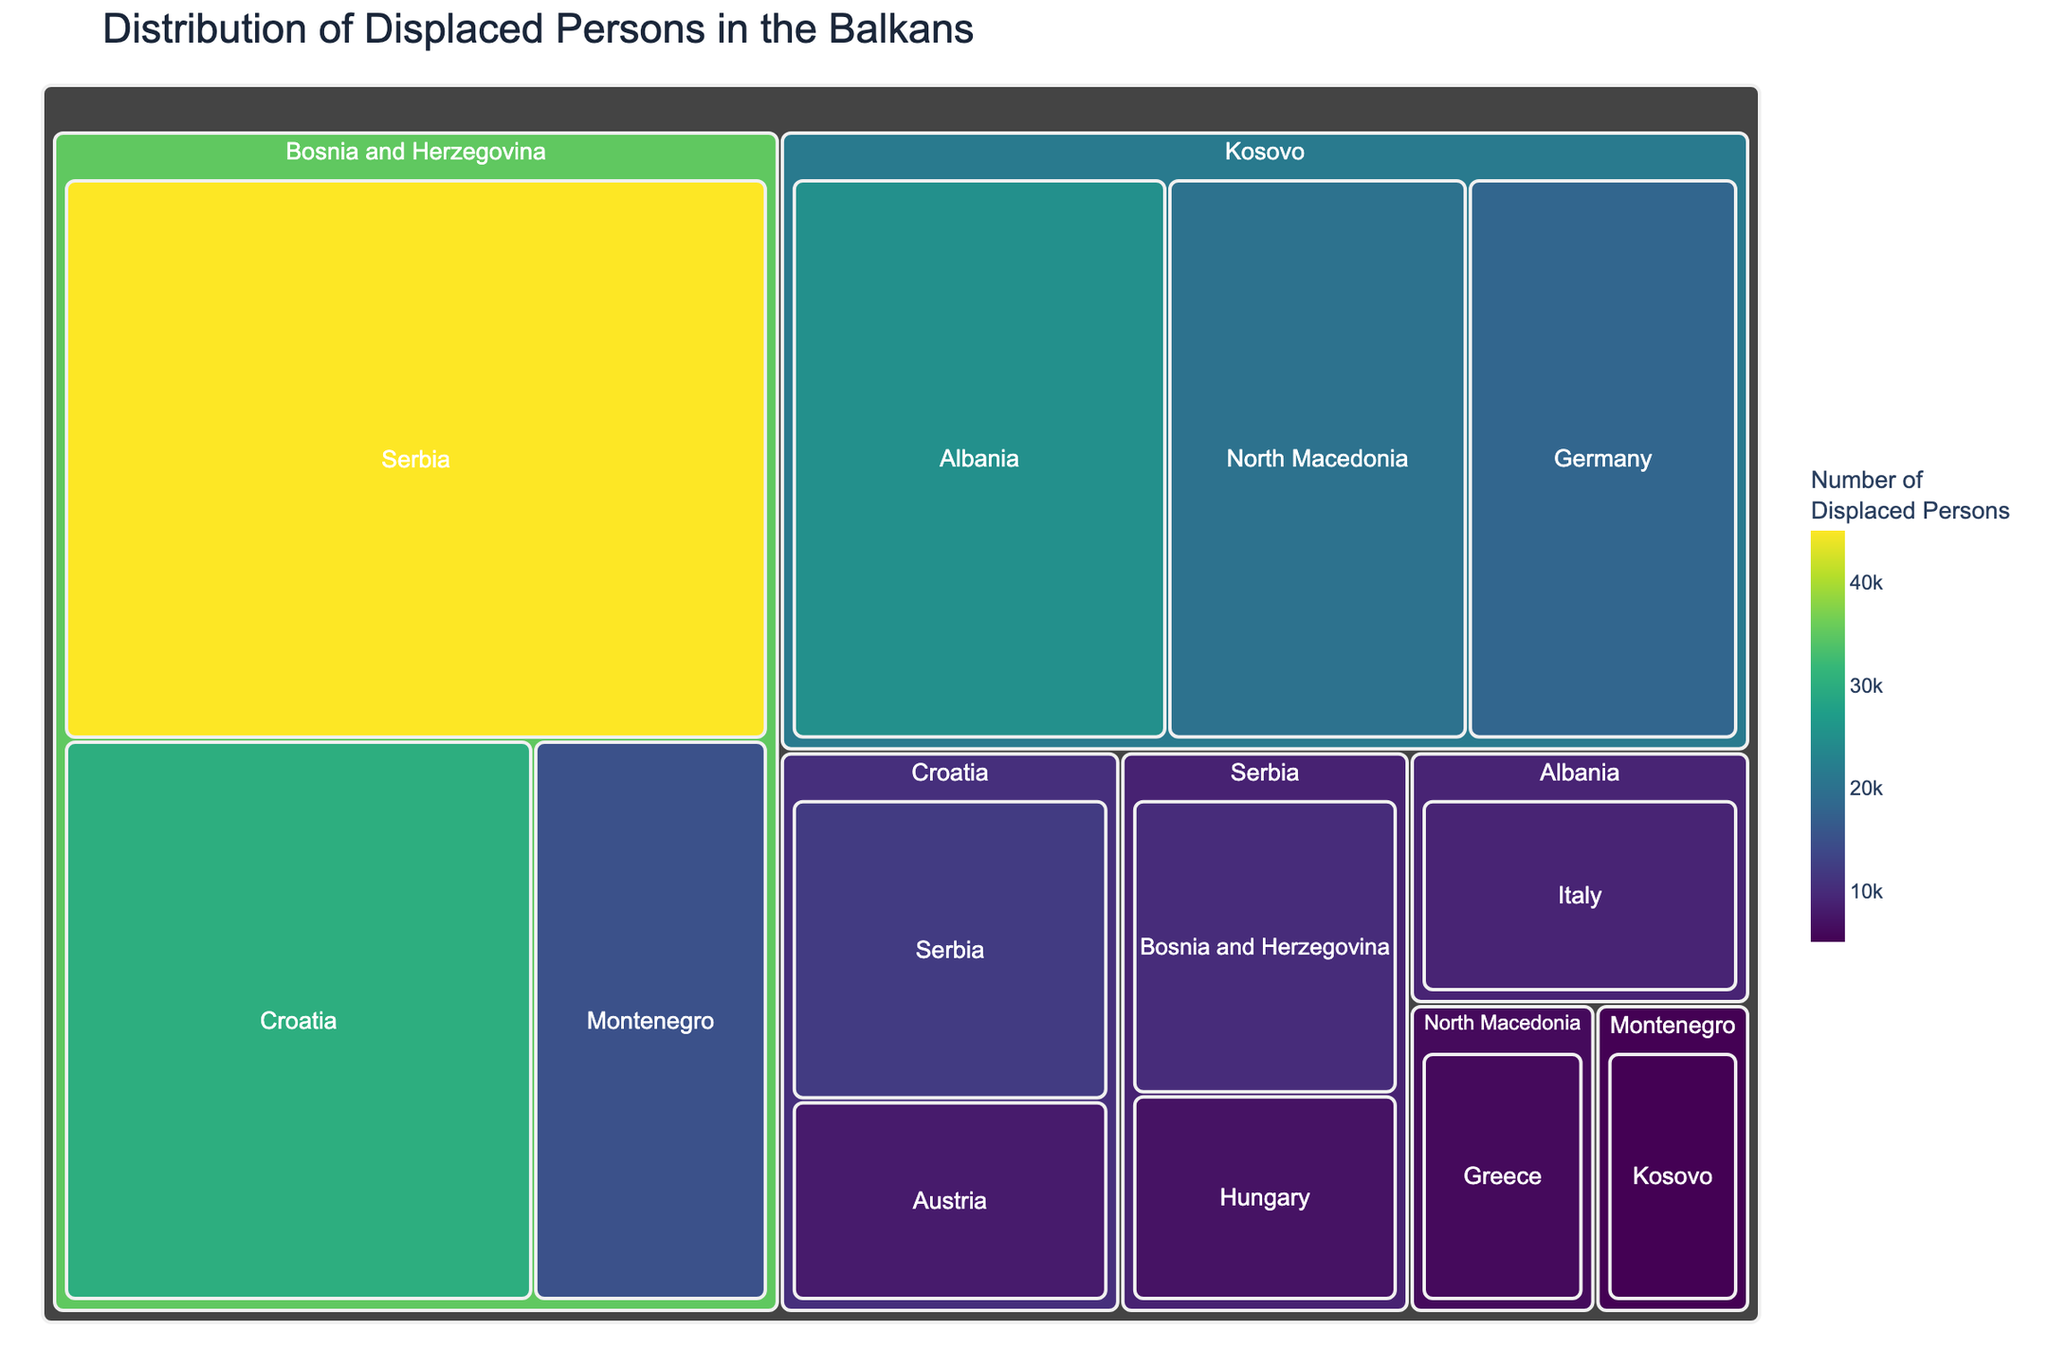Which country of origin has the highest number of displaced persons? The largest section in the treemap for a country of origin represents the highest number. In the given data, Bosnia and Herzegovina has a total of 90000 displaced persons (45000 + 30000 + 15000).
Answer: Bosnia and Herzegovina How many displaced persons from Kosovo are currently in Germany? Locate the section from Kosovo that specifies Germany as the current location in the treemap. The displayed value is 18000.
Answer: 18000 What is the total number of displaced persons currently located in Serbia? Sum the values of all sections under Serbia as the current location: 45000 (from Bosnia and Herzegovina) + 12000 (from Croatia) = 57000.
Answer: 57000 Which two countries have displaced persons currently living in Greece? Locate the section for Greece in the treemap to identify the countries of origin. The only section for Greece has North Macedonia as the country of origin.
Answer: North Macedonia Is the number of displaced persons from Albania higher in Italy or Germany? Find the sections for Albania under Italy and Kosovo under Germany. Albania has 9000 displaced persons in Italy, and Kosovo has 18000 displaced persons in Germany.
Answer: Germany (from Kosovo) What is the combined number of displaced persons with Bosnia and Herzegovina and Kosovo as their country of origin? Sum the values for Bosnia and Herzegovina (45000 + 30000 + 15000) and Kosovo (25000 + 20000 + 18000). The total is 90000 (Bosnia and Herzegovina) + 63000 (Kosovo) = 153000.
Answer: 153000 Which current location in the treemap holds the least number of displaced persons from Serbia? Locate the sections under Serbia and compare the numbers: 10000 (Bosnia and Herzegovina) and 7000 (Hungary). Hungary has the least.
Answer: Hungary How many countries of origin have displaced persons currently living in Croatia? Identify all sections under the current location "Croatia." The sections indicate Bosnia and Herzegovina as the only country of origin.
Answer: 1 Compare the number of displaced persons from North Macedonia and Montenegro. Which is higher? Sum the values for each country: North Macedonia has 6000 displaced persons, and Montenegro has 5000. North Macedonia is higher.
Answer: North Macedonia What is the total number of displaced persons currently residing in Austria and Italy combined? Sum the values of the sections under Austria (8000 from Croatia) and Italy (9000 from Albania). The total is 8000 + 9000 = 17000.
Answer: 17000 